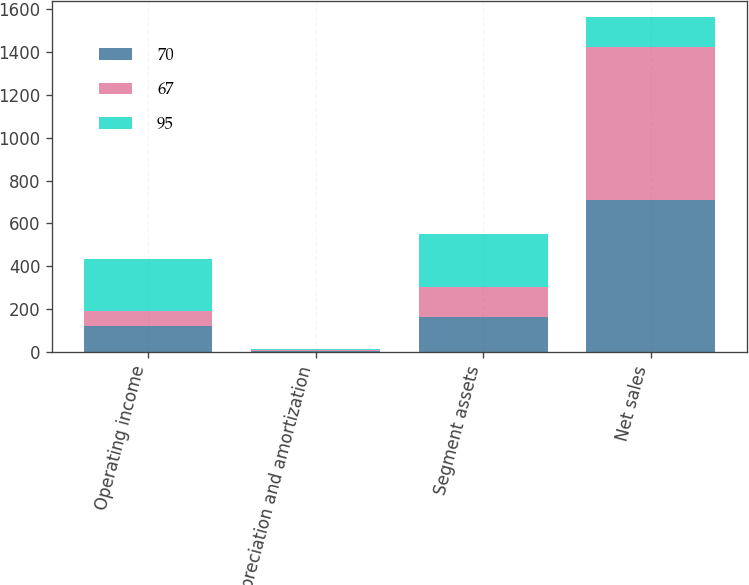Convert chart. <chart><loc_0><loc_0><loc_500><loc_500><stacked_bar_chart><ecel><fcel>Operating income<fcel>Depreciation and amortization<fcel>Segment assets<fcel>Net sales<nl><fcel>70<fcel>122<fcel>4<fcel>165<fcel>710<nl><fcel>67<fcel>68<fcel>6<fcel>137<fcel>713<nl><fcel>95<fcel>243<fcel>4<fcel>248<fcel>137<nl></chart> 